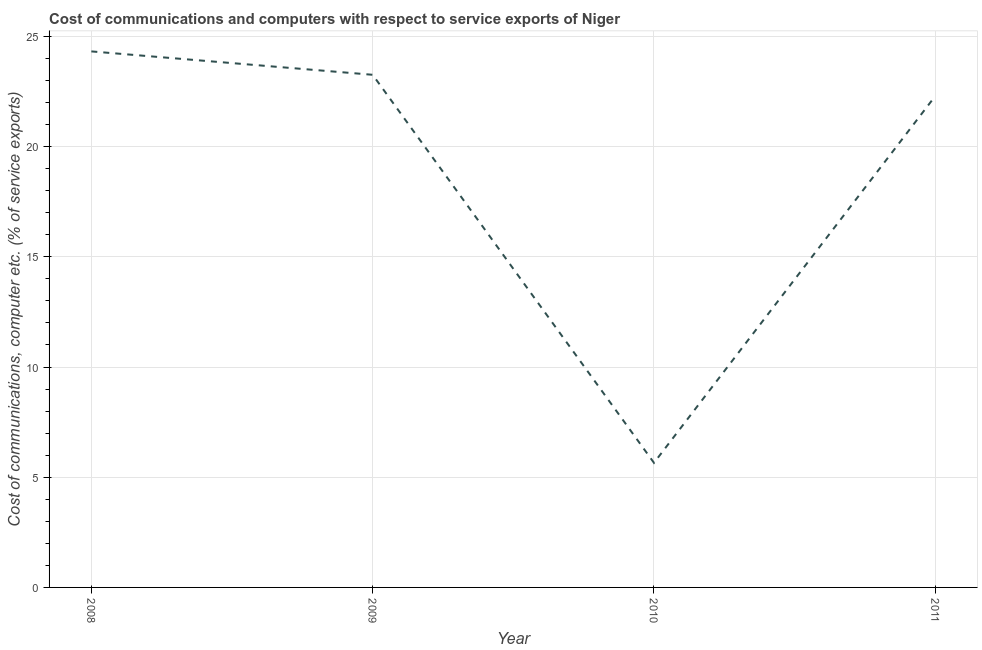What is the cost of communications and computer in 2008?
Provide a succinct answer. 24.32. Across all years, what is the maximum cost of communications and computer?
Ensure brevity in your answer.  24.32. Across all years, what is the minimum cost of communications and computer?
Provide a short and direct response. 5.65. What is the sum of the cost of communications and computer?
Your answer should be very brief. 75.53. What is the difference between the cost of communications and computer in 2010 and 2011?
Your response must be concise. -16.64. What is the average cost of communications and computer per year?
Keep it short and to the point. 18.88. What is the median cost of communications and computer?
Your answer should be very brief. 22.78. Do a majority of the years between 2010 and 2011 (inclusive) have cost of communications and computer greater than 21 %?
Make the answer very short. No. What is the ratio of the cost of communications and computer in 2009 to that in 2011?
Your answer should be compact. 1.04. Is the cost of communications and computer in 2008 less than that in 2011?
Provide a short and direct response. No. What is the difference between the highest and the second highest cost of communications and computer?
Provide a short and direct response. 1.06. Is the sum of the cost of communications and computer in 2010 and 2011 greater than the maximum cost of communications and computer across all years?
Your answer should be very brief. Yes. What is the difference between the highest and the lowest cost of communications and computer?
Give a very brief answer. 18.67. How many years are there in the graph?
Provide a succinct answer. 4. Are the values on the major ticks of Y-axis written in scientific E-notation?
Provide a short and direct response. No. Does the graph contain grids?
Provide a short and direct response. Yes. What is the title of the graph?
Ensure brevity in your answer.  Cost of communications and computers with respect to service exports of Niger. What is the label or title of the Y-axis?
Make the answer very short. Cost of communications, computer etc. (% of service exports). What is the Cost of communications, computer etc. (% of service exports) of 2008?
Give a very brief answer. 24.32. What is the Cost of communications, computer etc. (% of service exports) of 2009?
Offer a terse response. 23.26. What is the Cost of communications, computer etc. (% of service exports) of 2010?
Provide a succinct answer. 5.65. What is the Cost of communications, computer etc. (% of service exports) of 2011?
Make the answer very short. 22.3. What is the difference between the Cost of communications, computer etc. (% of service exports) in 2008 and 2009?
Ensure brevity in your answer.  1.06. What is the difference between the Cost of communications, computer etc. (% of service exports) in 2008 and 2010?
Provide a succinct answer. 18.67. What is the difference between the Cost of communications, computer etc. (% of service exports) in 2008 and 2011?
Provide a succinct answer. 2.02. What is the difference between the Cost of communications, computer etc. (% of service exports) in 2009 and 2010?
Keep it short and to the point. 17.61. What is the difference between the Cost of communications, computer etc. (% of service exports) in 2009 and 2011?
Keep it short and to the point. 0.96. What is the difference between the Cost of communications, computer etc. (% of service exports) in 2010 and 2011?
Give a very brief answer. -16.64. What is the ratio of the Cost of communications, computer etc. (% of service exports) in 2008 to that in 2009?
Provide a short and direct response. 1.05. What is the ratio of the Cost of communications, computer etc. (% of service exports) in 2008 to that in 2010?
Keep it short and to the point. 4.3. What is the ratio of the Cost of communications, computer etc. (% of service exports) in 2008 to that in 2011?
Give a very brief answer. 1.09. What is the ratio of the Cost of communications, computer etc. (% of service exports) in 2009 to that in 2010?
Make the answer very short. 4.11. What is the ratio of the Cost of communications, computer etc. (% of service exports) in 2009 to that in 2011?
Keep it short and to the point. 1.04. What is the ratio of the Cost of communications, computer etc. (% of service exports) in 2010 to that in 2011?
Your answer should be compact. 0.25. 